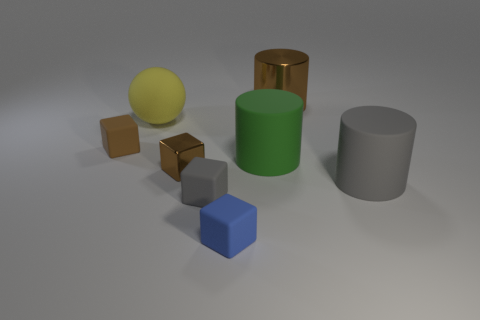What material is the big brown object?
Provide a succinct answer. Metal. What color is the matte cylinder that is on the left side of the big gray matte thing?
Ensure brevity in your answer.  Green. What number of matte cubes are the same color as the metallic cylinder?
Provide a succinct answer. 1. How many matte objects are in front of the large green rubber thing and to the left of the large metallic thing?
Offer a very short reply. 2. There is a gray object that is the same size as the brown metal cylinder; what shape is it?
Your answer should be very brief. Cylinder. The yellow rubber object is what size?
Your response must be concise. Large. What material is the brown thing to the left of the brown shiny thing in front of the yellow matte object in front of the brown cylinder?
Keep it short and to the point. Rubber. There is another big cylinder that is the same material as the big green cylinder; what is its color?
Keep it short and to the point. Gray. How many brown matte things are on the right side of the small rubber object that is behind the metal object left of the tiny blue matte thing?
Offer a very short reply. 0. What material is the other small object that is the same color as the tiny metallic thing?
Give a very brief answer. Rubber. 